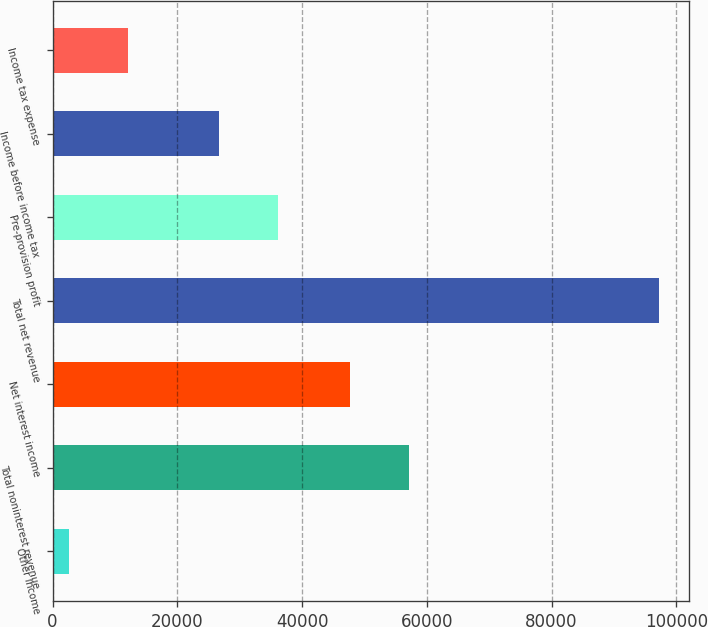Convert chart. <chart><loc_0><loc_0><loc_500><loc_500><bar_chart><fcel>Other income<fcel>Total noninterest revenue<fcel>Net interest income<fcel>Total net revenue<fcel>Pre-provision profit<fcel>Income before income tax<fcel>Income tax expense<nl><fcel>2605<fcel>57151.9<fcel>47689<fcel>97234<fcel>36211.9<fcel>26749<fcel>12067.9<nl></chart> 